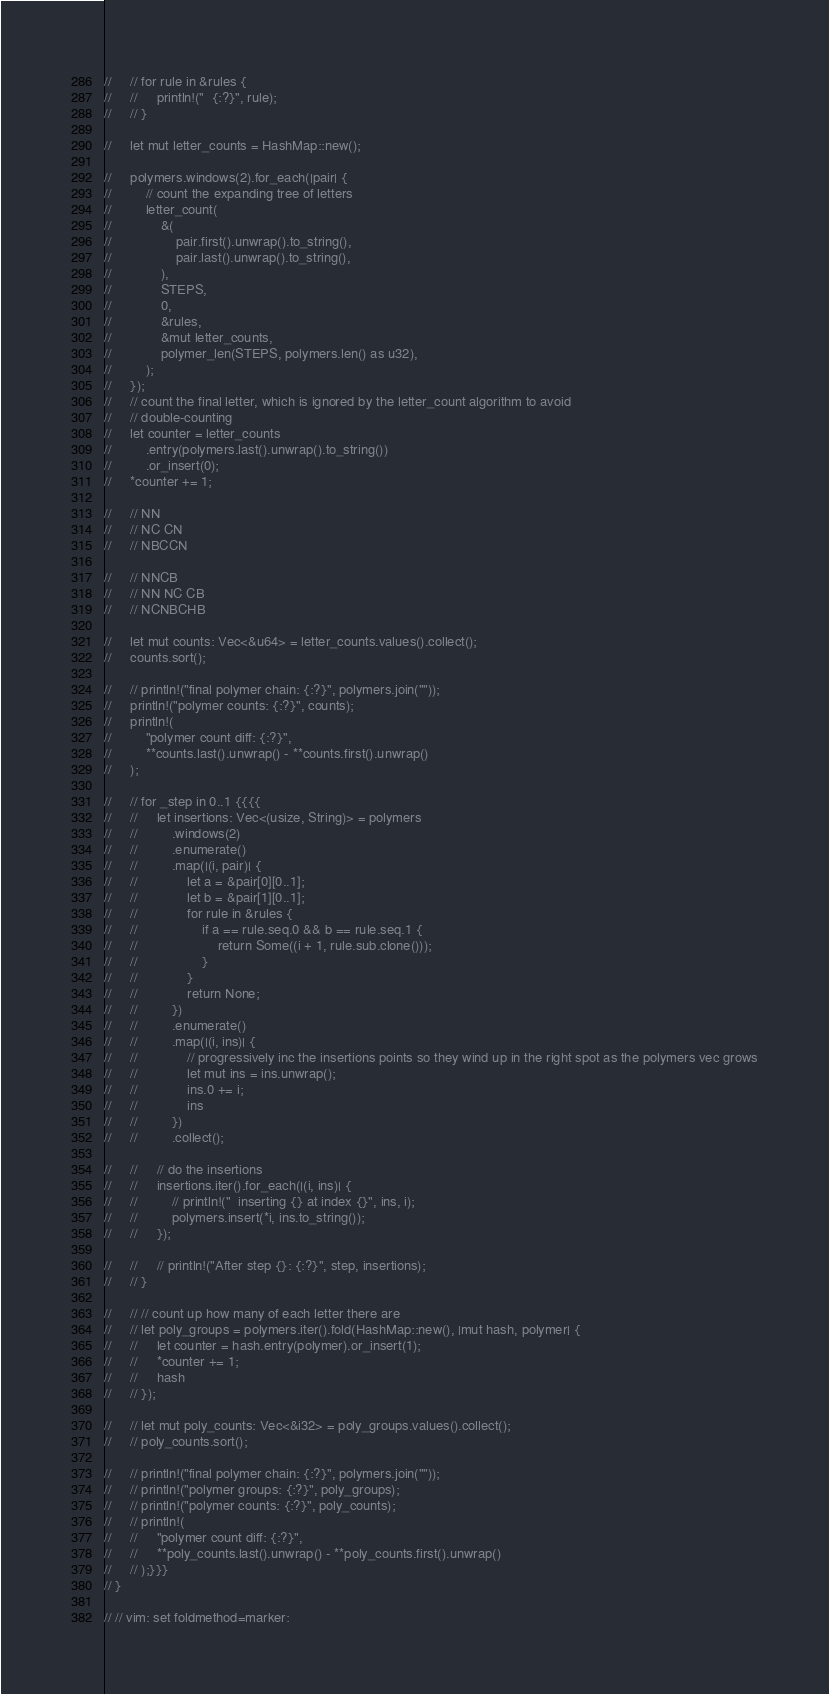Convert code to text. <code><loc_0><loc_0><loc_500><loc_500><_Rust_>//     // for rule in &rules {
//     //     println!("  {:?}", rule);
//     // }

//     let mut letter_counts = HashMap::new();

//     polymers.windows(2).for_each(|pair| {
//         // count the expanding tree of letters
//         letter_count(
//             &(
//                 pair.first().unwrap().to_string(),
//                 pair.last().unwrap().to_string(),
//             ),
//             STEPS,
//             0,
//             &rules,
//             &mut letter_counts,
//             polymer_len(STEPS, polymers.len() as u32),
//         );
//     });
//     // count the final letter, which is ignored by the letter_count algorithm to avoid
//     // double-counting
//     let counter = letter_counts
//         .entry(polymers.last().unwrap().to_string())
//         .or_insert(0);
//     *counter += 1;

//     // NN
//     // NC CN
//     // NBCCN

//     // NNCB
//     // NN NC CB
//     // NCNBCHB

//     let mut counts: Vec<&u64> = letter_counts.values().collect();
//     counts.sort();

//     // println!("final polymer chain: {:?}", polymers.join(""));
//     println!("polymer counts: {:?}", counts);
//     println!(
//         "polymer count diff: {:?}",
//         **counts.last().unwrap() - **counts.first().unwrap()
//     );

//     // for _step in 0..1 {{{{
//     //     let insertions: Vec<(usize, String)> = polymers
//     //         .windows(2)
//     //         .enumerate()
//     //         .map(|(i, pair)| {
//     //             let a = &pair[0][0..1];
//     //             let b = &pair[1][0..1];
//     //             for rule in &rules {
//     //                 if a == rule.seq.0 && b == rule.seq.1 {
//     //                     return Some((i + 1, rule.sub.clone()));
//     //                 }
//     //             }
//     //             return None;
//     //         })
//     //         .enumerate()
//     //         .map(|(i, ins)| {
//     //             // progressively inc the insertions points so they wind up in the right spot as the polymers vec grows
//     //             let mut ins = ins.unwrap();
//     //             ins.0 += i;
//     //             ins
//     //         })
//     //         .collect();

//     //     // do the insertions
//     //     insertions.iter().for_each(|(i, ins)| {
//     //         // println!("  inserting {} at index {}", ins, i);
//     //         polymers.insert(*i, ins.to_string());
//     //     });

//     //     // println!("After step {}: {:?}", step, insertions);
//     // }

//     // // count up how many of each letter there are
//     // let poly_groups = polymers.iter().fold(HashMap::new(), |mut hash, polymer| {
//     //     let counter = hash.entry(polymer).or_insert(1);
//     //     *counter += 1;
//     //     hash
//     // });

//     // let mut poly_counts: Vec<&i32> = poly_groups.values().collect();
//     // poly_counts.sort();

//     // println!("final polymer chain: {:?}", polymers.join(""));
//     // println!("polymer groups: {:?}", poly_groups);
//     // println!("polymer counts: {:?}", poly_counts);
//     // println!(
//     //     "polymer count diff: {:?}",
//     //     **poly_counts.last().unwrap() - **poly_counts.first().unwrap()
//     // );}}}
// }

// // vim: set foldmethod=marker:
</code> 